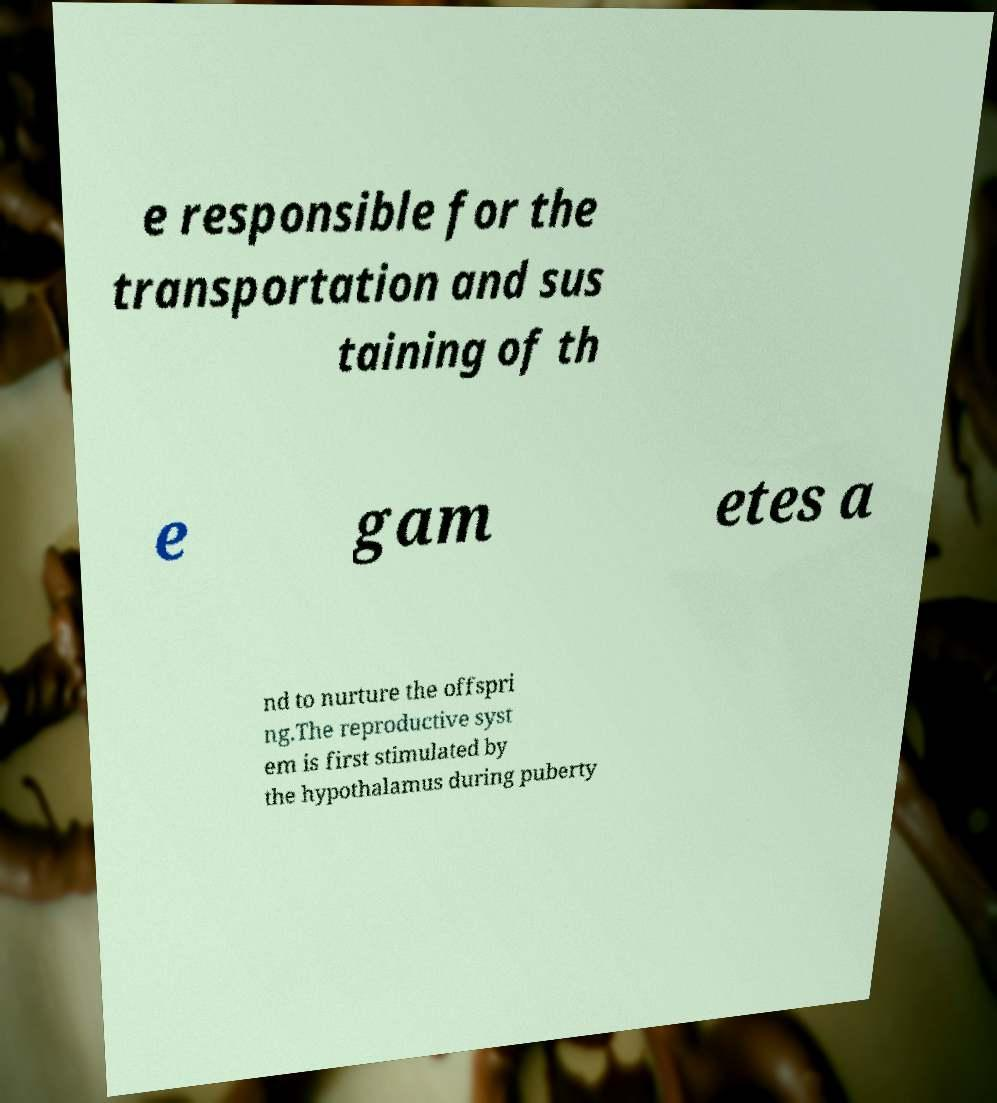Please identify and transcribe the text found in this image. e responsible for the transportation and sus taining of th e gam etes a nd to nurture the offspri ng.The reproductive syst em is first stimulated by the hypothalamus during puberty 